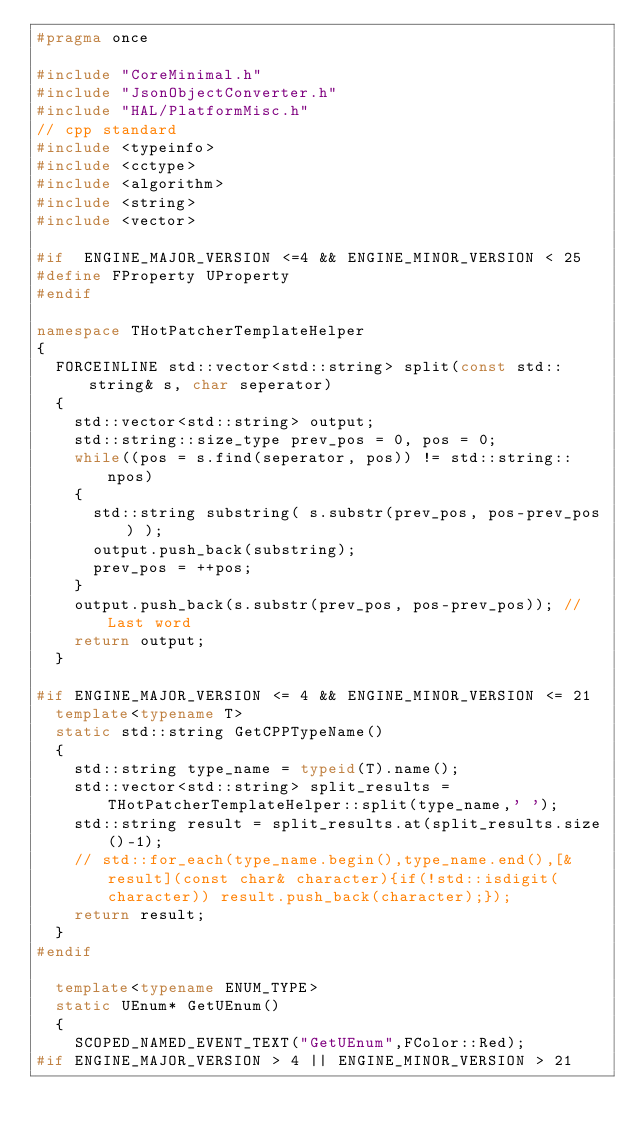Convert code to text. <code><loc_0><loc_0><loc_500><loc_500><_C++_>#pragma once

#include "CoreMinimal.h"
#include "JsonObjectConverter.h"
#include "HAL/PlatformMisc.h"
// cpp standard
#include <typeinfo>
#include <cctype>
#include <algorithm>
#include <string>
#include <vector>

#if  ENGINE_MAJOR_VERSION <=4 && ENGINE_MINOR_VERSION < 25
#define FProperty UProperty
#endif

namespace THotPatcherTemplateHelper
{
	FORCEINLINE std::vector<std::string> split(const std::string& s, char seperator)
	{
		std::vector<std::string> output;
		std::string::size_type prev_pos = 0, pos = 0;
		while((pos = s.find(seperator, pos)) != std::string::npos)
		{
			std::string substring( s.substr(prev_pos, pos-prev_pos) );
			output.push_back(substring);
			prev_pos = ++pos;
		}
		output.push_back(s.substr(prev_pos, pos-prev_pos)); // Last word
		return output;
	}
	
#if ENGINE_MAJOR_VERSION <= 4 && ENGINE_MINOR_VERSION <= 21
	template<typename T>
	static std::string GetCPPTypeName()
	{
		std::string type_name = typeid(T).name();
		std::vector<std::string> split_results = THotPatcherTemplateHelper::split(type_name,' ');
		std::string result = split_results.at(split_results.size()-1);
		// std::for_each(type_name.begin(),type_name.end(),[&result](const char& character){if(!std::isdigit(character)) result.push_back(character);});
		return result;
	}
#endif
	
	template<typename ENUM_TYPE>
	static UEnum* GetUEnum()
	{
		SCOPED_NAMED_EVENT_TEXT("GetUEnum",FColor::Red);
#if ENGINE_MAJOR_VERSION > 4 || ENGINE_MINOR_VERSION > 21</code> 